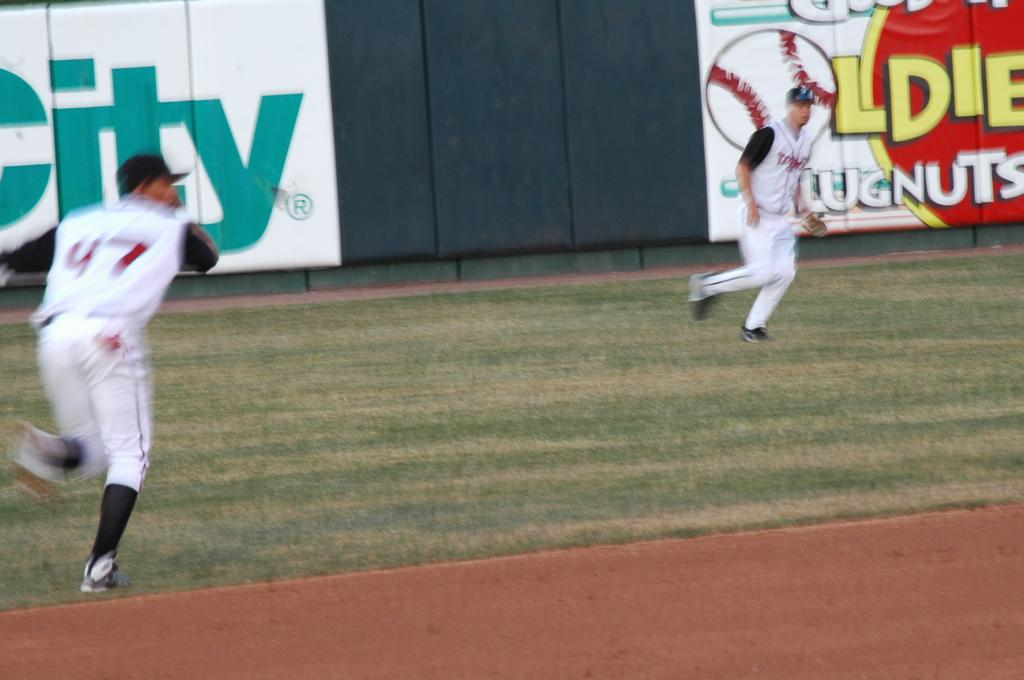<image>
Create a compact narrative representing the image presented. Two baseball players in front of a large ad that says City. 